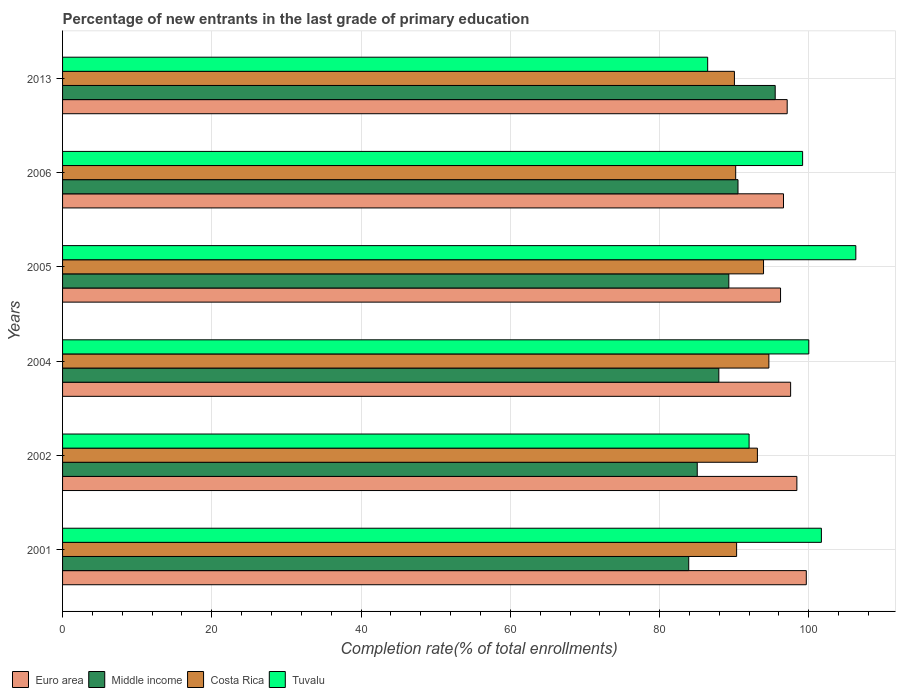How many different coloured bars are there?
Your answer should be compact. 4. Are the number of bars per tick equal to the number of legend labels?
Keep it short and to the point. Yes. What is the label of the 1st group of bars from the top?
Make the answer very short. 2013. What is the percentage of new entrants in Tuvalu in 2006?
Your answer should be very brief. 99.17. Across all years, what is the maximum percentage of new entrants in Middle income?
Make the answer very short. 95.5. Across all years, what is the minimum percentage of new entrants in Euro area?
Offer a very short reply. 96.21. What is the total percentage of new entrants in Tuvalu in the graph?
Give a very brief answer. 585.61. What is the difference between the percentage of new entrants in Euro area in 2004 and that in 2006?
Provide a succinct answer. 0.96. What is the difference between the percentage of new entrants in Middle income in 2004 and the percentage of new entrants in Tuvalu in 2006?
Keep it short and to the point. -11.23. What is the average percentage of new entrants in Tuvalu per year?
Provide a short and direct response. 97.6. In the year 2006, what is the difference between the percentage of new entrants in Costa Rica and percentage of new entrants in Middle income?
Provide a succinct answer. -0.31. What is the ratio of the percentage of new entrants in Euro area in 2004 to that in 2006?
Your answer should be compact. 1.01. Is the percentage of new entrants in Euro area in 2002 less than that in 2005?
Provide a succinct answer. No. Is the difference between the percentage of new entrants in Costa Rica in 2005 and 2006 greater than the difference between the percentage of new entrants in Middle income in 2005 and 2006?
Keep it short and to the point. Yes. What is the difference between the highest and the second highest percentage of new entrants in Middle income?
Provide a short and direct response. 4.98. What is the difference between the highest and the lowest percentage of new entrants in Tuvalu?
Make the answer very short. 19.85. In how many years, is the percentage of new entrants in Middle income greater than the average percentage of new entrants in Middle income taken over all years?
Provide a succinct answer. 3. Are all the bars in the graph horizontal?
Provide a short and direct response. Yes. What is the difference between two consecutive major ticks on the X-axis?
Make the answer very short. 20. Does the graph contain any zero values?
Ensure brevity in your answer.  No. Where does the legend appear in the graph?
Make the answer very short. Bottom left. How many legend labels are there?
Offer a terse response. 4. What is the title of the graph?
Your answer should be compact. Percentage of new entrants in the last grade of primary education. Does "Other small states" appear as one of the legend labels in the graph?
Make the answer very short. No. What is the label or title of the X-axis?
Offer a terse response. Completion rate(% of total enrollments). What is the Completion rate(% of total enrollments) in Euro area in 2001?
Give a very brief answer. 99.67. What is the Completion rate(% of total enrollments) of Middle income in 2001?
Keep it short and to the point. 83.91. What is the Completion rate(% of total enrollments) of Costa Rica in 2001?
Keep it short and to the point. 90.33. What is the Completion rate(% of total enrollments) in Tuvalu in 2001?
Offer a terse response. 101.69. What is the Completion rate(% of total enrollments) in Euro area in 2002?
Ensure brevity in your answer.  98.4. What is the Completion rate(% of total enrollments) in Middle income in 2002?
Your answer should be very brief. 85.05. What is the Completion rate(% of total enrollments) of Costa Rica in 2002?
Provide a succinct answer. 93.11. What is the Completion rate(% of total enrollments) of Tuvalu in 2002?
Keep it short and to the point. 92. What is the Completion rate(% of total enrollments) in Euro area in 2004?
Provide a short and direct response. 97.56. What is the Completion rate(% of total enrollments) in Middle income in 2004?
Give a very brief answer. 87.94. What is the Completion rate(% of total enrollments) in Costa Rica in 2004?
Offer a very short reply. 94.65. What is the Completion rate(% of total enrollments) of Euro area in 2005?
Your response must be concise. 96.21. What is the Completion rate(% of total enrollments) of Middle income in 2005?
Your answer should be very brief. 89.28. What is the Completion rate(% of total enrollments) of Costa Rica in 2005?
Your answer should be compact. 93.93. What is the Completion rate(% of total enrollments) of Tuvalu in 2005?
Keep it short and to the point. 106.3. What is the Completion rate(% of total enrollments) of Euro area in 2006?
Your answer should be very brief. 96.61. What is the Completion rate(% of total enrollments) of Middle income in 2006?
Your answer should be very brief. 90.51. What is the Completion rate(% of total enrollments) in Costa Rica in 2006?
Ensure brevity in your answer.  90.2. What is the Completion rate(% of total enrollments) of Tuvalu in 2006?
Make the answer very short. 99.17. What is the Completion rate(% of total enrollments) of Euro area in 2013?
Provide a short and direct response. 97.1. What is the Completion rate(% of total enrollments) of Middle income in 2013?
Offer a terse response. 95.5. What is the Completion rate(% of total enrollments) of Costa Rica in 2013?
Your response must be concise. 90.03. What is the Completion rate(% of total enrollments) in Tuvalu in 2013?
Provide a succinct answer. 86.45. Across all years, what is the maximum Completion rate(% of total enrollments) in Euro area?
Provide a short and direct response. 99.67. Across all years, what is the maximum Completion rate(% of total enrollments) in Middle income?
Make the answer very short. 95.5. Across all years, what is the maximum Completion rate(% of total enrollments) of Costa Rica?
Provide a succinct answer. 94.65. Across all years, what is the maximum Completion rate(% of total enrollments) in Tuvalu?
Provide a short and direct response. 106.3. Across all years, what is the minimum Completion rate(% of total enrollments) in Euro area?
Give a very brief answer. 96.21. Across all years, what is the minimum Completion rate(% of total enrollments) of Middle income?
Provide a short and direct response. 83.91. Across all years, what is the minimum Completion rate(% of total enrollments) in Costa Rica?
Your answer should be compact. 90.03. Across all years, what is the minimum Completion rate(% of total enrollments) of Tuvalu?
Offer a very short reply. 86.45. What is the total Completion rate(% of total enrollments) in Euro area in the graph?
Your answer should be compact. 585.56. What is the total Completion rate(% of total enrollments) of Middle income in the graph?
Offer a very short reply. 532.2. What is the total Completion rate(% of total enrollments) of Costa Rica in the graph?
Offer a terse response. 552.26. What is the total Completion rate(% of total enrollments) in Tuvalu in the graph?
Ensure brevity in your answer.  585.61. What is the difference between the Completion rate(% of total enrollments) of Euro area in 2001 and that in 2002?
Make the answer very short. 1.26. What is the difference between the Completion rate(% of total enrollments) of Middle income in 2001 and that in 2002?
Keep it short and to the point. -1.14. What is the difference between the Completion rate(% of total enrollments) in Costa Rica in 2001 and that in 2002?
Make the answer very short. -2.79. What is the difference between the Completion rate(% of total enrollments) in Tuvalu in 2001 and that in 2002?
Ensure brevity in your answer.  9.69. What is the difference between the Completion rate(% of total enrollments) in Euro area in 2001 and that in 2004?
Offer a terse response. 2.1. What is the difference between the Completion rate(% of total enrollments) of Middle income in 2001 and that in 2004?
Give a very brief answer. -4.03. What is the difference between the Completion rate(% of total enrollments) of Costa Rica in 2001 and that in 2004?
Your answer should be very brief. -4.32. What is the difference between the Completion rate(% of total enrollments) of Tuvalu in 2001 and that in 2004?
Ensure brevity in your answer.  1.69. What is the difference between the Completion rate(% of total enrollments) in Euro area in 2001 and that in 2005?
Your answer should be compact. 3.45. What is the difference between the Completion rate(% of total enrollments) of Middle income in 2001 and that in 2005?
Your answer should be very brief. -5.37. What is the difference between the Completion rate(% of total enrollments) of Costa Rica in 2001 and that in 2005?
Your answer should be compact. -3.61. What is the difference between the Completion rate(% of total enrollments) in Tuvalu in 2001 and that in 2005?
Provide a short and direct response. -4.61. What is the difference between the Completion rate(% of total enrollments) in Euro area in 2001 and that in 2006?
Give a very brief answer. 3.06. What is the difference between the Completion rate(% of total enrollments) of Middle income in 2001 and that in 2006?
Offer a terse response. -6.6. What is the difference between the Completion rate(% of total enrollments) of Costa Rica in 2001 and that in 2006?
Provide a short and direct response. 0.12. What is the difference between the Completion rate(% of total enrollments) of Tuvalu in 2001 and that in 2006?
Ensure brevity in your answer.  2.52. What is the difference between the Completion rate(% of total enrollments) in Euro area in 2001 and that in 2013?
Offer a very short reply. 2.56. What is the difference between the Completion rate(% of total enrollments) of Middle income in 2001 and that in 2013?
Offer a very short reply. -11.59. What is the difference between the Completion rate(% of total enrollments) of Costa Rica in 2001 and that in 2013?
Provide a short and direct response. 0.29. What is the difference between the Completion rate(% of total enrollments) in Tuvalu in 2001 and that in 2013?
Offer a terse response. 15.24. What is the difference between the Completion rate(% of total enrollments) of Euro area in 2002 and that in 2004?
Your response must be concise. 0.84. What is the difference between the Completion rate(% of total enrollments) in Middle income in 2002 and that in 2004?
Provide a succinct answer. -2.89. What is the difference between the Completion rate(% of total enrollments) in Costa Rica in 2002 and that in 2004?
Keep it short and to the point. -1.54. What is the difference between the Completion rate(% of total enrollments) in Euro area in 2002 and that in 2005?
Provide a succinct answer. 2.19. What is the difference between the Completion rate(% of total enrollments) in Middle income in 2002 and that in 2005?
Ensure brevity in your answer.  -4.23. What is the difference between the Completion rate(% of total enrollments) in Costa Rica in 2002 and that in 2005?
Offer a terse response. -0.82. What is the difference between the Completion rate(% of total enrollments) in Tuvalu in 2002 and that in 2005?
Your answer should be compact. -14.3. What is the difference between the Completion rate(% of total enrollments) of Euro area in 2002 and that in 2006?
Keep it short and to the point. 1.79. What is the difference between the Completion rate(% of total enrollments) in Middle income in 2002 and that in 2006?
Make the answer very short. -5.46. What is the difference between the Completion rate(% of total enrollments) in Costa Rica in 2002 and that in 2006?
Provide a short and direct response. 2.91. What is the difference between the Completion rate(% of total enrollments) of Tuvalu in 2002 and that in 2006?
Your answer should be very brief. -7.17. What is the difference between the Completion rate(% of total enrollments) in Euro area in 2002 and that in 2013?
Give a very brief answer. 1.3. What is the difference between the Completion rate(% of total enrollments) in Middle income in 2002 and that in 2013?
Give a very brief answer. -10.45. What is the difference between the Completion rate(% of total enrollments) in Costa Rica in 2002 and that in 2013?
Provide a short and direct response. 3.08. What is the difference between the Completion rate(% of total enrollments) of Tuvalu in 2002 and that in 2013?
Keep it short and to the point. 5.55. What is the difference between the Completion rate(% of total enrollments) in Euro area in 2004 and that in 2005?
Provide a short and direct response. 1.35. What is the difference between the Completion rate(% of total enrollments) of Middle income in 2004 and that in 2005?
Offer a terse response. -1.34. What is the difference between the Completion rate(% of total enrollments) in Costa Rica in 2004 and that in 2005?
Give a very brief answer. 0.72. What is the difference between the Completion rate(% of total enrollments) in Tuvalu in 2004 and that in 2005?
Your answer should be compact. -6.3. What is the difference between the Completion rate(% of total enrollments) in Euro area in 2004 and that in 2006?
Offer a terse response. 0.96. What is the difference between the Completion rate(% of total enrollments) of Middle income in 2004 and that in 2006?
Your response must be concise. -2.57. What is the difference between the Completion rate(% of total enrollments) in Costa Rica in 2004 and that in 2006?
Keep it short and to the point. 4.45. What is the difference between the Completion rate(% of total enrollments) in Tuvalu in 2004 and that in 2006?
Provide a succinct answer. 0.83. What is the difference between the Completion rate(% of total enrollments) in Euro area in 2004 and that in 2013?
Your answer should be very brief. 0.46. What is the difference between the Completion rate(% of total enrollments) in Middle income in 2004 and that in 2013?
Your response must be concise. -7.55. What is the difference between the Completion rate(% of total enrollments) in Costa Rica in 2004 and that in 2013?
Provide a short and direct response. 4.62. What is the difference between the Completion rate(% of total enrollments) of Tuvalu in 2004 and that in 2013?
Give a very brief answer. 13.55. What is the difference between the Completion rate(% of total enrollments) in Euro area in 2005 and that in 2006?
Make the answer very short. -0.39. What is the difference between the Completion rate(% of total enrollments) in Middle income in 2005 and that in 2006?
Your answer should be very brief. -1.23. What is the difference between the Completion rate(% of total enrollments) of Costa Rica in 2005 and that in 2006?
Make the answer very short. 3.73. What is the difference between the Completion rate(% of total enrollments) in Tuvalu in 2005 and that in 2006?
Provide a short and direct response. 7.13. What is the difference between the Completion rate(% of total enrollments) of Euro area in 2005 and that in 2013?
Offer a very short reply. -0.89. What is the difference between the Completion rate(% of total enrollments) of Middle income in 2005 and that in 2013?
Ensure brevity in your answer.  -6.21. What is the difference between the Completion rate(% of total enrollments) of Costa Rica in 2005 and that in 2013?
Your response must be concise. 3.9. What is the difference between the Completion rate(% of total enrollments) of Tuvalu in 2005 and that in 2013?
Keep it short and to the point. 19.85. What is the difference between the Completion rate(% of total enrollments) of Euro area in 2006 and that in 2013?
Ensure brevity in your answer.  -0.49. What is the difference between the Completion rate(% of total enrollments) of Middle income in 2006 and that in 2013?
Your answer should be very brief. -4.98. What is the difference between the Completion rate(% of total enrollments) of Costa Rica in 2006 and that in 2013?
Keep it short and to the point. 0.17. What is the difference between the Completion rate(% of total enrollments) in Tuvalu in 2006 and that in 2013?
Make the answer very short. 12.72. What is the difference between the Completion rate(% of total enrollments) in Euro area in 2001 and the Completion rate(% of total enrollments) in Middle income in 2002?
Provide a succinct answer. 14.61. What is the difference between the Completion rate(% of total enrollments) of Euro area in 2001 and the Completion rate(% of total enrollments) of Costa Rica in 2002?
Make the answer very short. 6.55. What is the difference between the Completion rate(% of total enrollments) in Euro area in 2001 and the Completion rate(% of total enrollments) in Tuvalu in 2002?
Ensure brevity in your answer.  7.67. What is the difference between the Completion rate(% of total enrollments) in Middle income in 2001 and the Completion rate(% of total enrollments) in Costa Rica in 2002?
Ensure brevity in your answer.  -9.2. What is the difference between the Completion rate(% of total enrollments) in Middle income in 2001 and the Completion rate(% of total enrollments) in Tuvalu in 2002?
Make the answer very short. -8.09. What is the difference between the Completion rate(% of total enrollments) of Costa Rica in 2001 and the Completion rate(% of total enrollments) of Tuvalu in 2002?
Make the answer very short. -1.67. What is the difference between the Completion rate(% of total enrollments) of Euro area in 2001 and the Completion rate(% of total enrollments) of Middle income in 2004?
Ensure brevity in your answer.  11.72. What is the difference between the Completion rate(% of total enrollments) of Euro area in 2001 and the Completion rate(% of total enrollments) of Costa Rica in 2004?
Make the answer very short. 5.01. What is the difference between the Completion rate(% of total enrollments) in Euro area in 2001 and the Completion rate(% of total enrollments) in Tuvalu in 2004?
Offer a very short reply. -0.33. What is the difference between the Completion rate(% of total enrollments) of Middle income in 2001 and the Completion rate(% of total enrollments) of Costa Rica in 2004?
Your answer should be compact. -10.74. What is the difference between the Completion rate(% of total enrollments) in Middle income in 2001 and the Completion rate(% of total enrollments) in Tuvalu in 2004?
Ensure brevity in your answer.  -16.09. What is the difference between the Completion rate(% of total enrollments) in Costa Rica in 2001 and the Completion rate(% of total enrollments) in Tuvalu in 2004?
Your response must be concise. -9.67. What is the difference between the Completion rate(% of total enrollments) in Euro area in 2001 and the Completion rate(% of total enrollments) in Middle income in 2005?
Offer a very short reply. 10.38. What is the difference between the Completion rate(% of total enrollments) of Euro area in 2001 and the Completion rate(% of total enrollments) of Costa Rica in 2005?
Your response must be concise. 5.73. What is the difference between the Completion rate(% of total enrollments) of Euro area in 2001 and the Completion rate(% of total enrollments) of Tuvalu in 2005?
Give a very brief answer. -6.64. What is the difference between the Completion rate(% of total enrollments) in Middle income in 2001 and the Completion rate(% of total enrollments) in Costa Rica in 2005?
Ensure brevity in your answer.  -10.02. What is the difference between the Completion rate(% of total enrollments) in Middle income in 2001 and the Completion rate(% of total enrollments) in Tuvalu in 2005?
Give a very brief answer. -22.39. What is the difference between the Completion rate(% of total enrollments) of Costa Rica in 2001 and the Completion rate(% of total enrollments) of Tuvalu in 2005?
Offer a very short reply. -15.98. What is the difference between the Completion rate(% of total enrollments) of Euro area in 2001 and the Completion rate(% of total enrollments) of Middle income in 2006?
Your answer should be compact. 9.15. What is the difference between the Completion rate(% of total enrollments) of Euro area in 2001 and the Completion rate(% of total enrollments) of Costa Rica in 2006?
Provide a succinct answer. 9.46. What is the difference between the Completion rate(% of total enrollments) of Euro area in 2001 and the Completion rate(% of total enrollments) of Tuvalu in 2006?
Your answer should be compact. 0.49. What is the difference between the Completion rate(% of total enrollments) in Middle income in 2001 and the Completion rate(% of total enrollments) in Costa Rica in 2006?
Ensure brevity in your answer.  -6.29. What is the difference between the Completion rate(% of total enrollments) of Middle income in 2001 and the Completion rate(% of total enrollments) of Tuvalu in 2006?
Your answer should be very brief. -15.26. What is the difference between the Completion rate(% of total enrollments) in Costa Rica in 2001 and the Completion rate(% of total enrollments) in Tuvalu in 2006?
Make the answer very short. -8.84. What is the difference between the Completion rate(% of total enrollments) in Euro area in 2001 and the Completion rate(% of total enrollments) in Middle income in 2013?
Ensure brevity in your answer.  4.17. What is the difference between the Completion rate(% of total enrollments) in Euro area in 2001 and the Completion rate(% of total enrollments) in Costa Rica in 2013?
Make the answer very short. 9.63. What is the difference between the Completion rate(% of total enrollments) of Euro area in 2001 and the Completion rate(% of total enrollments) of Tuvalu in 2013?
Make the answer very short. 13.22. What is the difference between the Completion rate(% of total enrollments) of Middle income in 2001 and the Completion rate(% of total enrollments) of Costa Rica in 2013?
Your response must be concise. -6.12. What is the difference between the Completion rate(% of total enrollments) in Middle income in 2001 and the Completion rate(% of total enrollments) in Tuvalu in 2013?
Your response must be concise. -2.54. What is the difference between the Completion rate(% of total enrollments) of Costa Rica in 2001 and the Completion rate(% of total enrollments) of Tuvalu in 2013?
Provide a succinct answer. 3.88. What is the difference between the Completion rate(% of total enrollments) of Euro area in 2002 and the Completion rate(% of total enrollments) of Middle income in 2004?
Provide a short and direct response. 10.46. What is the difference between the Completion rate(% of total enrollments) in Euro area in 2002 and the Completion rate(% of total enrollments) in Costa Rica in 2004?
Make the answer very short. 3.75. What is the difference between the Completion rate(% of total enrollments) in Euro area in 2002 and the Completion rate(% of total enrollments) in Tuvalu in 2004?
Give a very brief answer. -1.6. What is the difference between the Completion rate(% of total enrollments) of Middle income in 2002 and the Completion rate(% of total enrollments) of Costa Rica in 2004?
Your answer should be very brief. -9.6. What is the difference between the Completion rate(% of total enrollments) in Middle income in 2002 and the Completion rate(% of total enrollments) in Tuvalu in 2004?
Your answer should be very brief. -14.95. What is the difference between the Completion rate(% of total enrollments) of Costa Rica in 2002 and the Completion rate(% of total enrollments) of Tuvalu in 2004?
Give a very brief answer. -6.89. What is the difference between the Completion rate(% of total enrollments) of Euro area in 2002 and the Completion rate(% of total enrollments) of Middle income in 2005?
Offer a very short reply. 9.12. What is the difference between the Completion rate(% of total enrollments) in Euro area in 2002 and the Completion rate(% of total enrollments) in Costa Rica in 2005?
Make the answer very short. 4.47. What is the difference between the Completion rate(% of total enrollments) in Euro area in 2002 and the Completion rate(% of total enrollments) in Tuvalu in 2005?
Offer a terse response. -7.9. What is the difference between the Completion rate(% of total enrollments) of Middle income in 2002 and the Completion rate(% of total enrollments) of Costa Rica in 2005?
Offer a terse response. -8.88. What is the difference between the Completion rate(% of total enrollments) in Middle income in 2002 and the Completion rate(% of total enrollments) in Tuvalu in 2005?
Your answer should be very brief. -21.25. What is the difference between the Completion rate(% of total enrollments) of Costa Rica in 2002 and the Completion rate(% of total enrollments) of Tuvalu in 2005?
Your response must be concise. -13.19. What is the difference between the Completion rate(% of total enrollments) of Euro area in 2002 and the Completion rate(% of total enrollments) of Middle income in 2006?
Make the answer very short. 7.89. What is the difference between the Completion rate(% of total enrollments) in Euro area in 2002 and the Completion rate(% of total enrollments) in Costa Rica in 2006?
Offer a terse response. 8.2. What is the difference between the Completion rate(% of total enrollments) of Euro area in 2002 and the Completion rate(% of total enrollments) of Tuvalu in 2006?
Offer a terse response. -0.77. What is the difference between the Completion rate(% of total enrollments) of Middle income in 2002 and the Completion rate(% of total enrollments) of Costa Rica in 2006?
Your response must be concise. -5.15. What is the difference between the Completion rate(% of total enrollments) of Middle income in 2002 and the Completion rate(% of total enrollments) of Tuvalu in 2006?
Offer a terse response. -14.12. What is the difference between the Completion rate(% of total enrollments) of Costa Rica in 2002 and the Completion rate(% of total enrollments) of Tuvalu in 2006?
Keep it short and to the point. -6.06. What is the difference between the Completion rate(% of total enrollments) of Euro area in 2002 and the Completion rate(% of total enrollments) of Middle income in 2013?
Offer a very short reply. 2.9. What is the difference between the Completion rate(% of total enrollments) of Euro area in 2002 and the Completion rate(% of total enrollments) of Costa Rica in 2013?
Offer a terse response. 8.37. What is the difference between the Completion rate(% of total enrollments) of Euro area in 2002 and the Completion rate(% of total enrollments) of Tuvalu in 2013?
Provide a succinct answer. 11.95. What is the difference between the Completion rate(% of total enrollments) in Middle income in 2002 and the Completion rate(% of total enrollments) in Costa Rica in 2013?
Offer a terse response. -4.98. What is the difference between the Completion rate(% of total enrollments) in Middle income in 2002 and the Completion rate(% of total enrollments) in Tuvalu in 2013?
Provide a short and direct response. -1.4. What is the difference between the Completion rate(% of total enrollments) in Costa Rica in 2002 and the Completion rate(% of total enrollments) in Tuvalu in 2013?
Offer a very short reply. 6.66. What is the difference between the Completion rate(% of total enrollments) in Euro area in 2004 and the Completion rate(% of total enrollments) in Middle income in 2005?
Offer a very short reply. 8.28. What is the difference between the Completion rate(% of total enrollments) of Euro area in 2004 and the Completion rate(% of total enrollments) of Costa Rica in 2005?
Your response must be concise. 3.63. What is the difference between the Completion rate(% of total enrollments) of Euro area in 2004 and the Completion rate(% of total enrollments) of Tuvalu in 2005?
Ensure brevity in your answer.  -8.74. What is the difference between the Completion rate(% of total enrollments) in Middle income in 2004 and the Completion rate(% of total enrollments) in Costa Rica in 2005?
Your answer should be very brief. -5.99. What is the difference between the Completion rate(% of total enrollments) in Middle income in 2004 and the Completion rate(% of total enrollments) in Tuvalu in 2005?
Your response must be concise. -18.36. What is the difference between the Completion rate(% of total enrollments) in Costa Rica in 2004 and the Completion rate(% of total enrollments) in Tuvalu in 2005?
Ensure brevity in your answer.  -11.65. What is the difference between the Completion rate(% of total enrollments) in Euro area in 2004 and the Completion rate(% of total enrollments) in Middle income in 2006?
Ensure brevity in your answer.  7.05. What is the difference between the Completion rate(% of total enrollments) in Euro area in 2004 and the Completion rate(% of total enrollments) in Costa Rica in 2006?
Keep it short and to the point. 7.36. What is the difference between the Completion rate(% of total enrollments) in Euro area in 2004 and the Completion rate(% of total enrollments) in Tuvalu in 2006?
Keep it short and to the point. -1.61. What is the difference between the Completion rate(% of total enrollments) of Middle income in 2004 and the Completion rate(% of total enrollments) of Costa Rica in 2006?
Offer a terse response. -2.26. What is the difference between the Completion rate(% of total enrollments) of Middle income in 2004 and the Completion rate(% of total enrollments) of Tuvalu in 2006?
Offer a very short reply. -11.23. What is the difference between the Completion rate(% of total enrollments) in Costa Rica in 2004 and the Completion rate(% of total enrollments) in Tuvalu in 2006?
Offer a very short reply. -4.52. What is the difference between the Completion rate(% of total enrollments) of Euro area in 2004 and the Completion rate(% of total enrollments) of Middle income in 2013?
Offer a very short reply. 2.07. What is the difference between the Completion rate(% of total enrollments) in Euro area in 2004 and the Completion rate(% of total enrollments) in Costa Rica in 2013?
Give a very brief answer. 7.53. What is the difference between the Completion rate(% of total enrollments) of Euro area in 2004 and the Completion rate(% of total enrollments) of Tuvalu in 2013?
Make the answer very short. 11.12. What is the difference between the Completion rate(% of total enrollments) in Middle income in 2004 and the Completion rate(% of total enrollments) in Costa Rica in 2013?
Make the answer very short. -2.09. What is the difference between the Completion rate(% of total enrollments) in Middle income in 2004 and the Completion rate(% of total enrollments) in Tuvalu in 2013?
Provide a short and direct response. 1.49. What is the difference between the Completion rate(% of total enrollments) of Costa Rica in 2004 and the Completion rate(% of total enrollments) of Tuvalu in 2013?
Provide a short and direct response. 8.2. What is the difference between the Completion rate(% of total enrollments) in Euro area in 2005 and the Completion rate(% of total enrollments) in Middle income in 2006?
Make the answer very short. 5.7. What is the difference between the Completion rate(% of total enrollments) of Euro area in 2005 and the Completion rate(% of total enrollments) of Costa Rica in 2006?
Provide a succinct answer. 6.01. What is the difference between the Completion rate(% of total enrollments) of Euro area in 2005 and the Completion rate(% of total enrollments) of Tuvalu in 2006?
Give a very brief answer. -2.96. What is the difference between the Completion rate(% of total enrollments) of Middle income in 2005 and the Completion rate(% of total enrollments) of Costa Rica in 2006?
Your answer should be compact. -0.92. What is the difference between the Completion rate(% of total enrollments) in Middle income in 2005 and the Completion rate(% of total enrollments) in Tuvalu in 2006?
Provide a short and direct response. -9.89. What is the difference between the Completion rate(% of total enrollments) of Costa Rica in 2005 and the Completion rate(% of total enrollments) of Tuvalu in 2006?
Your answer should be very brief. -5.24. What is the difference between the Completion rate(% of total enrollments) of Euro area in 2005 and the Completion rate(% of total enrollments) of Middle income in 2013?
Give a very brief answer. 0.72. What is the difference between the Completion rate(% of total enrollments) in Euro area in 2005 and the Completion rate(% of total enrollments) in Costa Rica in 2013?
Give a very brief answer. 6.18. What is the difference between the Completion rate(% of total enrollments) of Euro area in 2005 and the Completion rate(% of total enrollments) of Tuvalu in 2013?
Keep it short and to the point. 9.77. What is the difference between the Completion rate(% of total enrollments) of Middle income in 2005 and the Completion rate(% of total enrollments) of Costa Rica in 2013?
Your response must be concise. -0.75. What is the difference between the Completion rate(% of total enrollments) of Middle income in 2005 and the Completion rate(% of total enrollments) of Tuvalu in 2013?
Give a very brief answer. 2.83. What is the difference between the Completion rate(% of total enrollments) of Costa Rica in 2005 and the Completion rate(% of total enrollments) of Tuvalu in 2013?
Give a very brief answer. 7.48. What is the difference between the Completion rate(% of total enrollments) in Euro area in 2006 and the Completion rate(% of total enrollments) in Middle income in 2013?
Keep it short and to the point. 1.11. What is the difference between the Completion rate(% of total enrollments) of Euro area in 2006 and the Completion rate(% of total enrollments) of Costa Rica in 2013?
Your answer should be compact. 6.58. What is the difference between the Completion rate(% of total enrollments) of Euro area in 2006 and the Completion rate(% of total enrollments) of Tuvalu in 2013?
Your answer should be compact. 10.16. What is the difference between the Completion rate(% of total enrollments) in Middle income in 2006 and the Completion rate(% of total enrollments) in Costa Rica in 2013?
Offer a terse response. 0.48. What is the difference between the Completion rate(% of total enrollments) of Middle income in 2006 and the Completion rate(% of total enrollments) of Tuvalu in 2013?
Provide a succinct answer. 4.06. What is the difference between the Completion rate(% of total enrollments) of Costa Rica in 2006 and the Completion rate(% of total enrollments) of Tuvalu in 2013?
Your answer should be compact. 3.75. What is the average Completion rate(% of total enrollments) of Euro area per year?
Make the answer very short. 97.59. What is the average Completion rate(% of total enrollments) in Middle income per year?
Offer a terse response. 88.7. What is the average Completion rate(% of total enrollments) in Costa Rica per year?
Provide a short and direct response. 92.04. What is the average Completion rate(% of total enrollments) in Tuvalu per year?
Offer a very short reply. 97.6. In the year 2001, what is the difference between the Completion rate(% of total enrollments) of Euro area and Completion rate(% of total enrollments) of Middle income?
Offer a very short reply. 15.76. In the year 2001, what is the difference between the Completion rate(% of total enrollments) of Euro area and Completion rate(% of total enrollments) of Costa Rica?
Ensure brevity in your answer.  9.34. In the year 2001, what is the difference between the Completion rate(% of total enrollments) in Euro area and Completion rate(% of total enrollments) in Tuvalu?
Provide a succinct answer. -2.02. In the year 2001, what is the difference between the Completion rate(% of total enrollments) in Middle income and Completion rate(% of total enrollments) in Costa Rica?
Your answer should be very brief. -6.42. In the year 2001, what is the difference between the Completion rate(% of total enrollments) of Middle income and Completion rate(% of total enrollments) of Tuvalu?
Provide a short and direct response. -17.78. In the year 2001, what is the difference between the Completion rate(% of total enrollments) of Costa Rica and Completion rate(% of total enrollments) of Tuvalu?
Provide a short and direct response. -11.36. In the year 2002, what is the difference between the Completion rate(% of total enrollments) of Euro area and Completion rate(% of total enrollments) of Middle income?
Your response must be concise. 13.35. In the year 2002, what is the difference between the Completion rate(% of total enrollments) in Euro area and Completion rate(% of total enrollments) in Costa Rica?
Provide a short and direct response. 5.29. In the year 2002, what is the difference between the Completion rate(% of total enrollments) of Euro area and Completion rate(% of total enrollments) of Tuvalu?
Offer a terse response. 6.4. In the year 2002, what is the difference between the Completion rate(% of total enrollments) of Middle income and Completion rate(% of total enrollments) of Costa Rica?
Your answer should be very brief. -8.06. In the year 2002, what is the difference between the Completion rate(% of total enrollments) of Middle income and Completion rate(% of total enrollments) of Tuvalu?
Ensure brevity in your answer.  -6.95. In the year 2002, what is the difference between the Completion rate(% of total enrollments) in Costa Rica and Completion rate(% of total enrollments) in Tuvalu?
Ensure brevity in your answer.  1.11. In the year 2004, what is the difference between the Completion rate(% of total enrollments) in Euro area and Completion rate(% of total enrollments) in Middle income?
Provide a succinct answer. 9.62. In the year 2004, what is the difference between the Completion rate(% of total enrollments) of Euro area and Completion rate(% of total enrollments) of Costa Rica?
Offer a very short reply. 2.91. In the year 2004, what is the difference between the Completion rate(% of total enrollments) in Euro area and Completion rate(% of total enrollments) in Tuvalu?
Your answer should be compact. -2.44. In the year 2004, what is the difference between the Completion rate(% of total enrollments) in Middle income and Completion rate(% of total enrollments) in Costa Rica?
Offer a very short reply. -6.71. In the year 2004, what is the difference between the Completion rate(% of total enrollments) in Middle income and Completion rate(% of total enrollments) in Tuvalu?
Give a very brief answer. -12.06. In the year 2004, what is the difference between the Completion rate(% of total enrollments) of Costa Rica and Completion rate(% of total enrollments) of Tuvalu?
Your answer should be very brief. -5.35. In the year 2005, what is the difference between the Completion rate(% of total enrollments) in Euro area and Completion rate(% of total enrollments) in Middle income?
Provide a succinct answer. 6.93. In the year 2005, what is the difference between the Completion rate(% of total enrollments) in Euro area and Completion rate(% of total enrollments) in Costa Rica?
Make the answer very short. 2.28. In the year 2005, what is the difference between the Completion rate(% of total enrollments) in Euro area and Completion rate(% of total enrollments) in Tuvalu?
Make the answer very short. -10.09. In the year 2005, what is the difference between the Completion rate(% of total enrollments) of Middle income and Completion rate(% of total enrollments) of Costa Rica?
Give a very brief answer. -4.65. In the year 2005, what is the difference between the Completion rate(% of total enrollments) of Middle income and Completion rate(% of total enrollments) of Tuvalu?
Offer a very short reply. -17.02. In the year 2005, what is the difference between the Completion rate(% of total enrollments) of Costa Rica and Completion rate(% of total enrollments) of Tuvalu?
Give a very brief answer. -12.37. In the year 2006, what is the difference between the Completion rate(% of total enrollments) in Euro area and Completion rate(% of total enrollments) in Middle income?
Make the answer very short. 6.1. In the year 2006, what is the difference between the Completion rate(% of total enrollments) in Euro area and Completion rate(% of total enrollments) in Costa Rica?
Your response must be concise. 6.41. In the year 2006, what is the difference between the Completion rate(% of total enrollments) in Euro area and Completion rate(% of total enrollments) in Tuvalu?
Your answer should be very brief. -2.56. In the year 2006, what is the difference between the Completion rate(% of total enrollments) of Middle income and Completion rate(% of total enrollments) of Costa Rica?
Give a very brief answer. 0.31. In the year 2006, what is the difference between the Completion rate(% of total enrollments) in Middle income and Completion rate(% of total enrollments) in Tuvalu?
Give a very brief answer. -8.66. In the year 2006, what is the difference between the Completion rate(% of total enrollments) in Costa Rica and Completion rate(% of total enrollments) in Tuvalu?
Provide a succinct answer. -8.97. In the year 2013, what is the difference between the Completion rate(% of total enrollments) of Euro area and Completion rate(% of total enrollments) of Middle income?
Provide a short and direct response. 1.61. In the year 2013, what is the difference between the Completion rate(% of total enrollments) of Euro area and Completion rate(% of total enrollments) of Costa Rica?
Give a very brief answer. 7.07. In the year 2013, what is the difference between the Completion rate(% of total enrollments) of Euro area and Completion rate(% of total enrollments) of Tuvalu?
Offer a very short reply. 10.65. In the year 2013, what is the difference between the Completion rate(% of total enrollments) of Middle income and Completion rate(% of total enrollments) of Costa Rica?
Your response must be concise. 5.47. In the year 2013, what is the difference between the Completion rate(% of total enrollments) in Middle income and Completion rate(% of total enrollments) in Tuvalu?
Provide a succinct answer. 9.05. In the year 2013, what is the difference between the Completion rate(% of total enrollments) in Costa Rica and Completion rate(% of total enrollments) in Tuvalu?
Ensure brevity in your answer.  3.58. What is the ratio of the Completion rate(% of total enrollments) of Euro area in 2001 to that in 2002?
Ensure brevity in your answer.  1.01. What is the ratio of the Completion rate(% of total enrollments) of Middle income in 2001 to that in 2002?
Offer a terse response. 0.99. What is the ratio of the Completion rate(% of total enrollments) in Costa Rica in 2001 to that in 2002?
Provide a short and direct response. 0.97. What is the ratio of the Completion rate(% of total enrollments) in Tuvalu in 2001 to that in 2002?
Ensure brevity in your answer.  1.11. What is the ratio of the Completion rate(% of total enrollments) of Euro area in 2001 to that in 2004?
Your answer should be very brief. 1.02. What is the ratio of the Completion rate(% of total enrollments) of Middle income in 2001 to that in 2004?
Give a very brief answer. 0.95. What is the ratio of the Completion rate(% of total enrollments) of Costa Rica in 2001 to that in 2004?
Your answer should be compact. 0.95. What is the ratio of the Completion rate(% of total enrollments) in Tuvalu in 2001 to that in 2004?
Offer a very short reply. 1.02. What is the ratio of the Completion rate(% of total enrollments) of Euro area in 2001 to that in 2005?
Offer a very short reply. 1.04. What is the ratio of the Completion rate(% of total enrollments) in Middle income in 2001 to that in 2005?
Your answer should be very brief. 0.94. What is the ratio of the Completion rate(% of total enrollments) in Costa Rica in 2001 to that in 2005?
Give a very brief answer. 0.96. What is the ratio of the Completion rate(% of total enrollments) in Tuvalu in 2001 to that in 2005?
Provide a succinct answer. 0.96. What is the ratio of the Completion rate(% of total enrollments) in Euro area in 2001 to that in 2006?
Offer a very short reply. 1.03. What is the ratio of the Completion rate(% of total enrollments) in Middle income in 2001 to that in 2006?
Give a very brief answer. 0.93. What is the ratio of the Completion rate(% of total enrollments) in Costa Rica in 2001 to that in 2006?
Provide a short and direct response. 1. What is the ratio of the Completion rate(% of total enrollments) in Tuvalu in 2001 to that in 2006?
Your answer should be compact. 1.03. What is the ratio of the Completion rate(% of total enrollments) of Euro area in 2001 to that in 2013?
Your answer should be compact. 1.03. What is the ratio of the Completion rate(% of total enrollments) in Middle income in 2001 to that in 2013?
Ensure brevity in your answer.  0.88. What is the ratio of the Completion rate(% of total enrollments) in Tuvalu in 2001 to that in 2013?
Ensure brevity in your answer.  1.18. What is the ratio of the Completion rate(% of total enrollments) in Euro area in 2002 to that in 2004?
Give a very brief answer. 1.01. What is the ratio of the Completion rate(% of total enrollments) of Middle income in 2002 to that in 2004?
Your response must be concise. 0.97. What is the ratio of the Completion rate(% of total enrollments) of Costa Rica in 2002 to that in 2004?
Your answer should be compact. 0.98. What is the ratio of the Completion rate(% of total enrollments) of Euro area in 2002 to that in 2005?
Your answer should be very brief. 1.02. What is the ratio of the Completion rate(% of total enrollments) in Middle income in 2002 to that in 2005?
Provide a succinct answer. 0.95. What is the ratio of the Completion rate(% of total enrollments) in Tuvalu in 2002 to that in 2005?
Give a very brief answer. 0.87. What is the ratio of the Completion rate(% of total enrollments) in Euro area in 2002 to that in 2006?
Make the answer very short. 1.02. What is the ratio of the Completion rate(% of total enrollments) in Middle income in 2002 to that in 2006?
Give a very brief answer. 0.94. What is the ratio of the Completion rate(% of total enrollments) in Costa Rica in 2002 to that in 2006?
Your answer should be compact. 1.03. What is the ratio of the Completion rate(% of total enrollments) of Tuvalu in 2002 to that in 2006?
Your answer should be very brief. 0.93. What is the ratio of the Completion rate(% of total enrollments) of Euro area in 2002 to that in 2013?
Keep it short and to the point. 1.01. What is the ratio of the Completion rate(% of total enrollments) in Middle income in 2002 to that in 2013?
Your answer should be very brief. 0.89. What is the ratio of the Completion rate(% of total enrollments) of Costa Rica in 2002 to that in 2013?
Keep it short and to the point. 1.03. What is the ratio of the Completion rate(% of total enrollments) in Tuvalu in 2002 to that in 2013?
Provide a succinct answer. 1.06. What is the ratio of the Completion rate(% of total enrollments) of Middle income in 2004 to that in 2005?
Provide a succinct answer. 0.98. What is the ratio of the Completion rate(% of total enrollments) in Costa Rica in 2004 to that in 2005?
Provide a succinct answer. 1.01. What is the ratio of the Completion rate(% of total enrollments) of Tuvalu in 2004 to that in 2005?
Offer a terse response. 0.94. What is the ratio of the Completion rate(% of total enrollments) of Euro area in 2004 to that in 2006?
Offer a terse response. 1.01. What is the ratio of the Completion rate(% of total enrollments) of Middle income in 2004 to that in 2006?
Your response must be concise. 0.97. What is the ratio of the Completion rate(% of total enrollments) in Costa Rica in 2004 to that in 2006?
Offer a very short reply. 1.05. What is the ratio of the Completion rate(% of total enrollments) in Tuvalu in 2004 to that in 2006?
Make the answer very short. 1.01. What is the ratio of the Completion rate(% of total enrollments) of Euro area in 2004 to that in 2013?
Provide a succinct answer. 1. What is the ratio of the Completion rate(% of total enrollments) of Middle income in 2004 to that in 2013?
Ensure brevity in your answer.  0.92. What is the ratio of the Completion rate(% of total enrollments) of Costa Rica in 2004 to that in 2013?
Keep it short and to the point. 1.05. What is the ratio of the Completion rate(% of total enrollments) of Tuvalu in 2004 to that in 2013?
Provide a succinct answer. 1.16. What is the ratio of the Completion rate(% of total enrollments) in Euro area in 2005 to that in 2006?
Provide a succinct answer. 1. What is the ratio of the Completion rate(% of total enrollments) of Middle income in 2005 to that in 2006?
Provide a succinct answer. 0.99. What is the ratio of the Completion rate(% of total enrollments) in Costa Rica in 2005 to that in 2006?
Keep it short and to the point. 1.04. What is the ratio of the Completion rate(% of total enrollments) of Tuvalu in 2005 to that in 2006?
Keep it short and to the point. 1.07. What is the ratio of the Completion rate(% of total enrollments) in Euro area in 2005 to that in 2013?
Your response must be concise. 0.99. What is the ratio of the Completion rate(% of total enrollments) of Middle income in 2005 to that in 2013?
Provide a short and direct response. 0.93. What is the ratio of the Completion rate(% of total enrollments) of Costa Rica in 2005 to that in 2013?
Your response must be concise. 1.04. What is the ratio of the Completion rate(% of total enrollments) of Tuvalu in 2005 to that in 2013?
Give a very brief answer. 1.23. What is the ratio of the Completion rate(% of total enrollments) in Euro area in 2006 to that in 2013?
Make the answer very short. 0.99. What is the ratio of the Completion rate(% of total enrollments) in Middle income in 2006 to that in 2013?
Make the answer very short. 0.95. What is the ratio of the Completion rate(% of total enrollments) in Costa Rica in 2006 to that in 2013?
Ensure brevity in your answer.  1. What is the ratio of the Completion rate(% of total enrollments) of Tuvalu in 2006 to that in 2013?
Provide a short and direct response. 1.15. What is the difference between the highest and the second highest Completion rate(% of total enrollments) in Euro area?
Offer a very short reply. 1.26. What is the difference between the highest and the second highest Completion rate(% of total enrollments) in Middle income?
Keep it short and to the point. 4.98. What is the difference between the highest and the second highest Completion rate(% of total enrollments) in Costa Rica?
Keep it short and to the point. 0.72. What is the difference between the highest and the second highest Completion rate(% of total enrollments) of Tuvalu?
Ensure brevity in your answer.  4.61. What is the difference between the highest and the lowest Completion rate(% of total enrollments) in Euro area?
Your response must be concise. 3.45. What is the difference between the highest and the lowest Completion rate(% of total enrollments) in Middle income?
Keep it short and to the point. 11.59. What is the difference between the highest and the lowest Completion rate(% of total enrollments) in Costa Rica?
Keep it short and to the point. 4.62. What is the difference between the highest and the lowest Completion rate(% of total enrollments) of Tuvalu?
Provide a short and direct response. 19.85. 